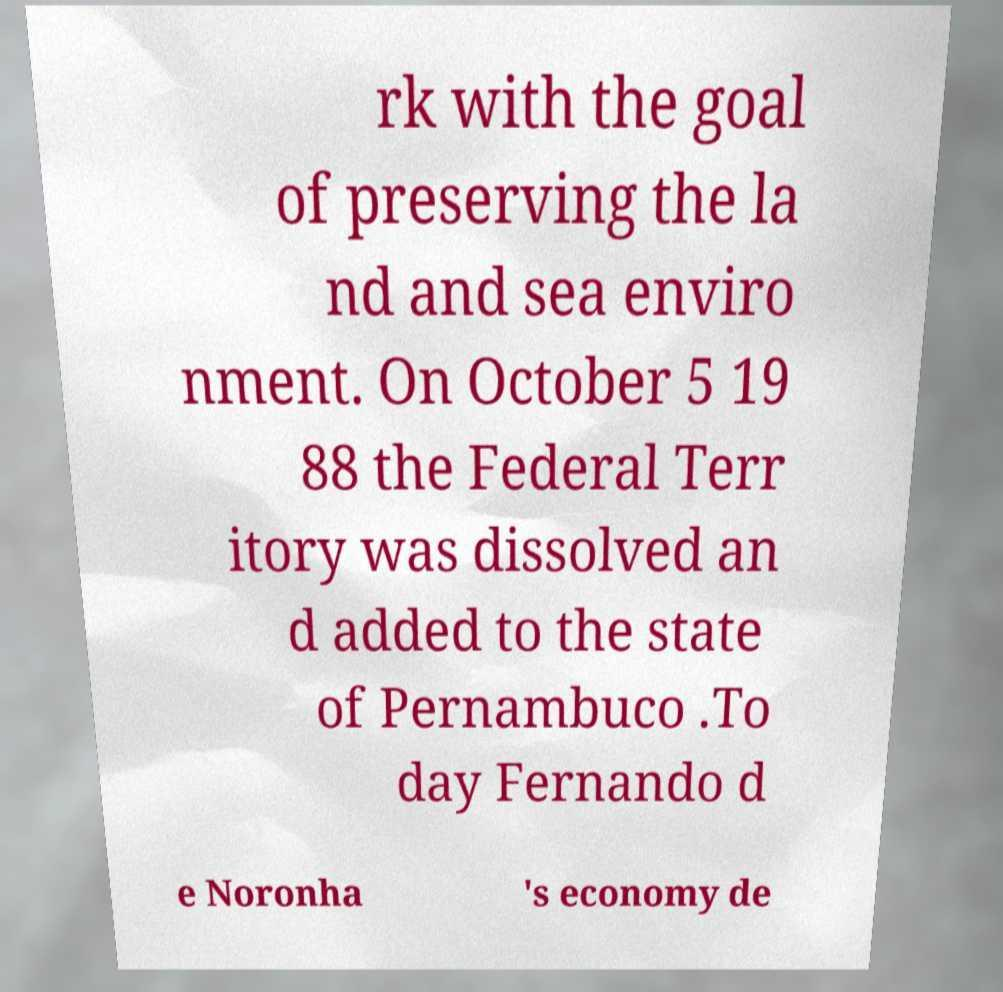I need the written content from this picture converted into text. Can you do that? rk with the goal of preserving the la nd and sea enviro nment. On October 5 19 88 the Federal Terr itory was dissolved an d added to the state of Pernambuco .To day Fernando d e Noronha 's economy de 